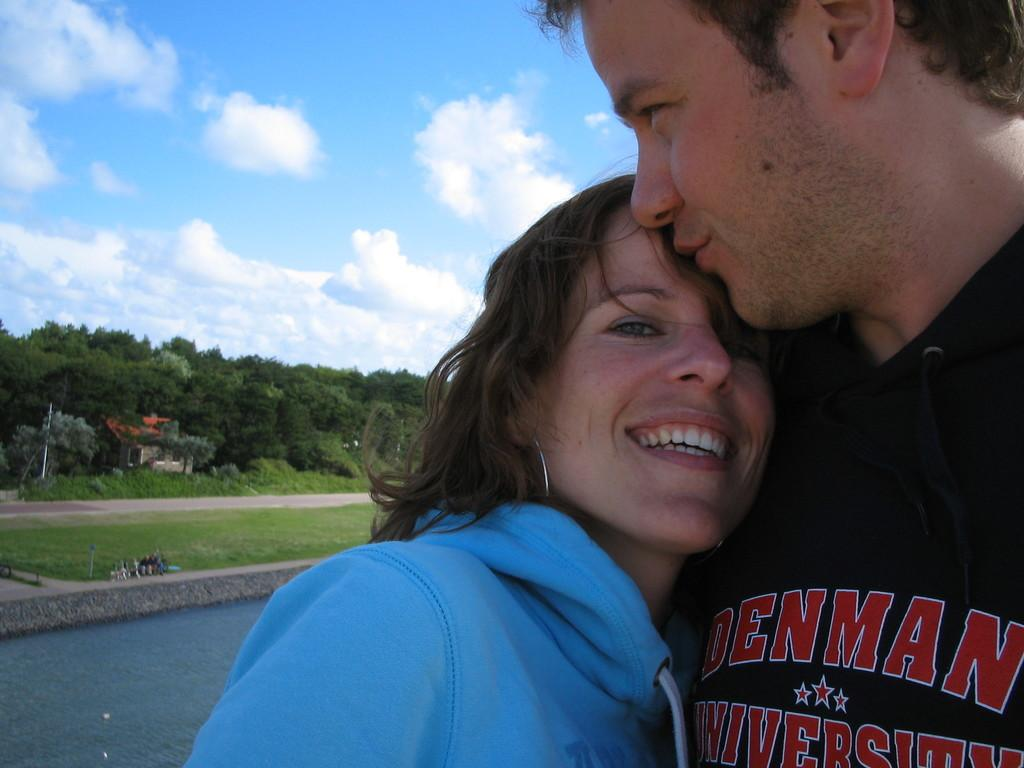How many people are present in the image? There are persons in the image, but the exact number cannot be determined from the provided facts. What can be seen in the background of the image? In the background of the image, there is water, a building, a group of trees, poles, and a cloudy sky. What type of environment is depicted in the image? The image shows a scene with water, trees, and a building, suggesting a natural or semi-natural setting. What type of potato is being harvested by the persons in the image? There is no mention of potatoes or any harvesting activity in the image. 